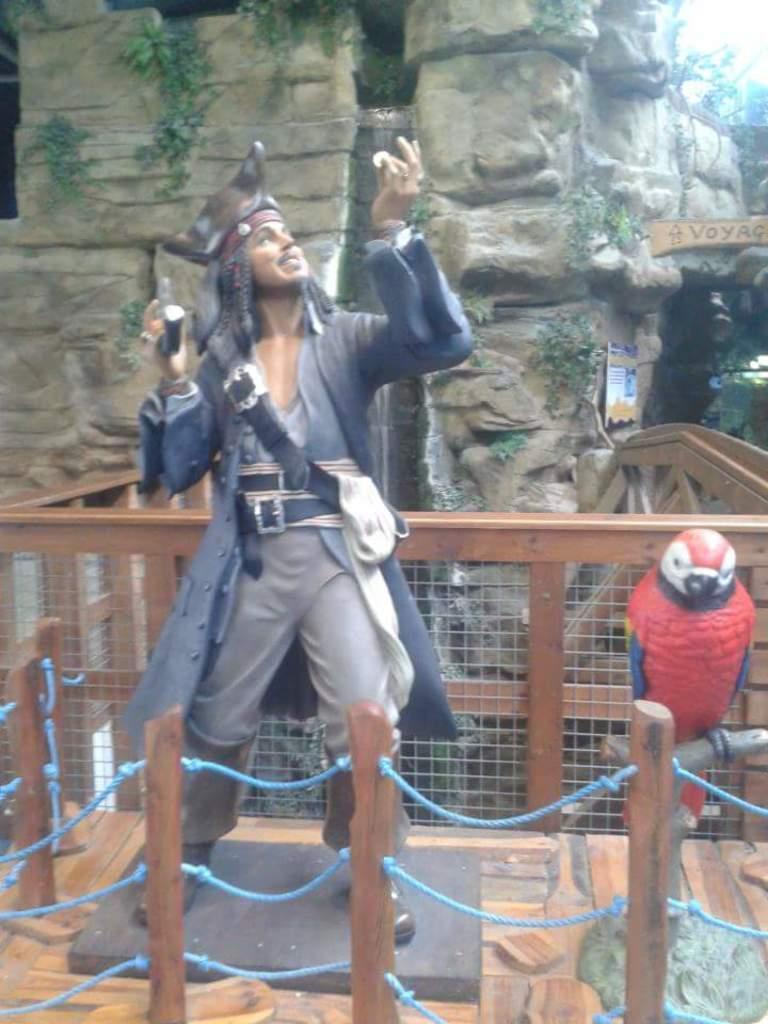Can you describe this image briefly? In this image in the center there is a man standing. In the front there is a wooden stand and on the right side there is a bird standing. In the background there is a fence and there is a wall. 